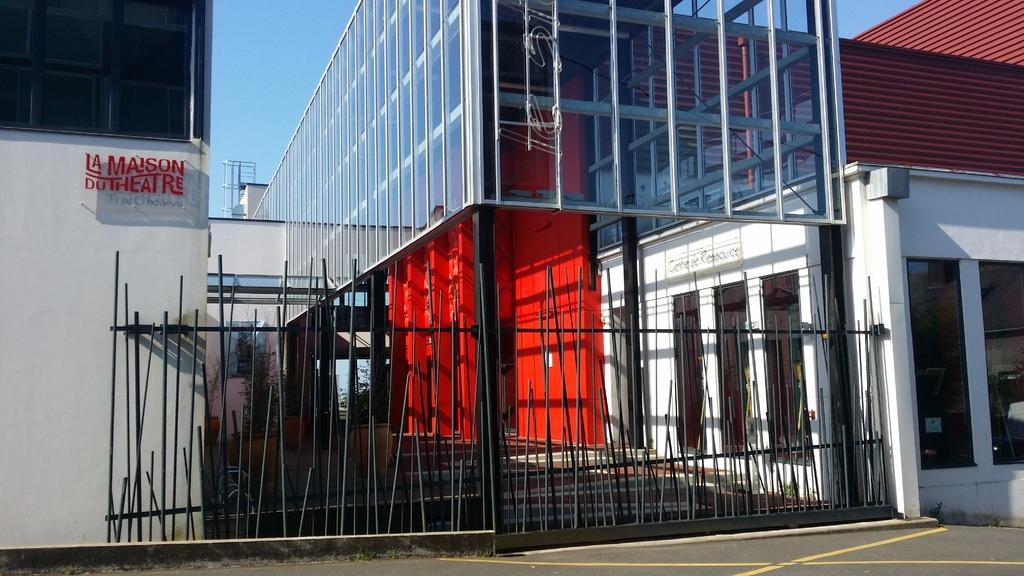What structure is present in the foreground of the image? There is a gate in the image. What can be seen in the background of the image? There is a building with glass windows in the background. What type of vegetation is visible in the image? Plants are visible in the image. What is the color of the sky in the image? The sky is blue in color. Who is cooking in the image? There is no one cooking in the image; it does not depict any cooking activity. 